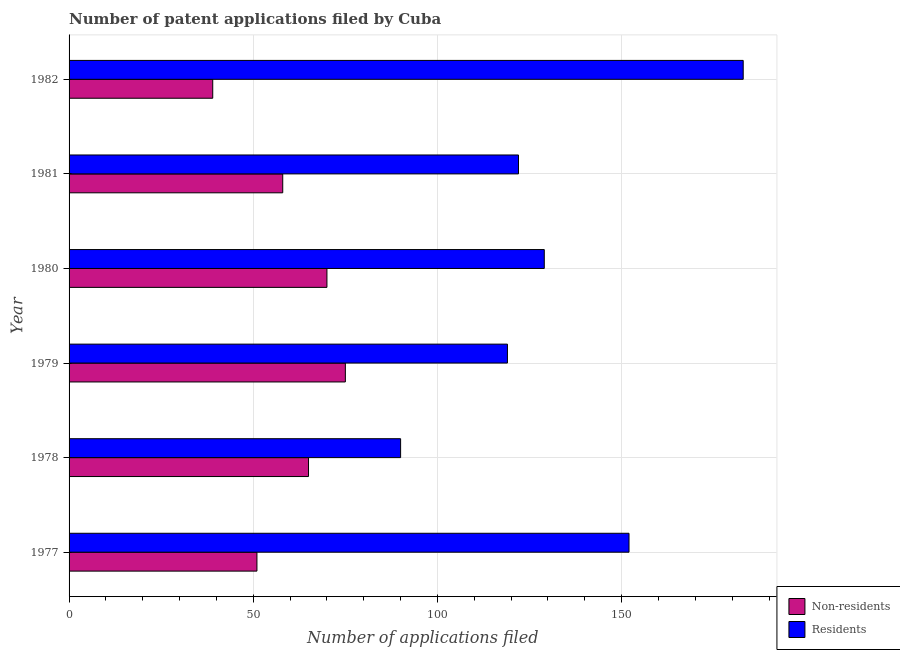How many different coloured bars are there?
Provide a short and direct response. 2. How many groups of bars are there?
Give a very brief answer. 6. What is the number of patent applications by residents in 1980?
Your answer should be very brief. 129. Across all years, what is the maximum number of patent applications by non residents?
Give a very brief answer. 75. Across all years, what is the minimum number of patent applications by residents?
Your answer should be compact. 90. In which year was the number of patent applications by residents maximum?
Provide a short and direct response. 1982. In which year was the number of patent applications by residents minimum?
Offer a terse response. 1978. What is the total number of patent applications by non residents in the graph?
Keep it short and to the point. 358. What is the difference between the number of patent applications by residents in 1978 and that in 1979?
Your answer should be compact. -29. What is the difference between the number of patent applications by residents in 1980 and the number of patent applications by non residents in 1977?
Give a very brief answer. 78. What is the average number of patent applications by residents per year?
Your answer should be compact. 132.5. In the year 1978, what is the difference between the number of patent applications by residents and number of patent applications by non residents?
Offer a terse response. 25. What is the ratio of the number of patent applications by residents in 1979 to that in 1980?
Your answer should be compact. 0.92. Is the number of patent applications by non residents in 1978 less than that in 1981?
Offer a terse response. No. What is the difference between the highest and the lowest number of patent applications by residents?
Provide a short and direct response. 93. In how many years, is the number of patent applications by non residents greater than the average number of patent applications by non residents taken over all years?
Give a very brief answer. 3. Is the sum of the number of patent applications by non residents in 1980 and 1981 greater than the maximum number of patent applications by residents across all years?
Keep it short and to the point. No. What does the 1st bar from the top in 1979 represents?
Your answer should be very brief. Residents. What does the 1st bar from the bottom in 1978 represents?
Keep it short and to the point. Non-residents. How many years are there in the graph?
Your answer should be compact. 6. Does the graph contain grids?
Your answer should be very brief. Yes. How are the legend labels stacked?
Provide a succinct answer. Vertical. What is the title of the graph?
Ensure brevity in your answer.  Number of patent applications filed by Cuba. What is the label or title of the X-axis?
Offer a very short reply. Number of applications filed. What is the label or title of the Y-axis?
Provide a succinct answer. Year. What is the Number of applications filed in Residents in 1977?
Ensure brevity in your answer.  152. What is the Number of applications filed of Residents in 1979?
Your response must be concise. 119. What is the Number of applications filed of Residents in 1980?
Provide a succinct answer. 129. What is the Number of applications filed in Residents in 1981?
Provide a succinct answer. 122. What is the Number of applications filed of Residents in 1982?
Ensure brevity in your answer.  183. Across all years, what is the maximum Number of applications filed in Residents?
Make the answer very short. 183. Across all years, what is the minimum Number of applications filed in Residents?
Keep it short and to the point. 90. What is the total Number of applications filed in Non-residents in the graph?
Offer a very short reply. 358. What is the total Number of applications filed in Residents in the graph?
Offer a terse response. 795. What is the difference between the Number of applications filed of Non-residents in 1977 and that in 1979?
Your answer should be compact. -24. What is the difference between the Number of applications filed in Residents in 1977 and that in 1980?
Ensure brevity in your answer.  23. What is the difference between the Number of applications filed in Residents in 1977 and that in 1981?
Offer a terse response. 30. What is the difference between the Number of applications filed in Residents in 1977 and that in 1982?
Provide a succinct answer. -31. What is the difference between the Number of applications filed of Non-residents in 1978 and that in 1979?
Your answer should be compact. -10. What is the difference between the Number of applications filed in Residents in 1978 and that in 1979?
Provide a short and direct response. -29. What is the difference between the Number of applications filed in Residents in 1978 and that in 1980?
Provide a short and direct response. -39. What is the difference between the Number of applications filed of Residents in 1978 and that in 1981?
Your response must be concise. -32. What is the difference between the Number of applications filed in Residents in 1978 and that in 1982?
Give a very brief answer. -93. What is the difference between the Number of applications filed in Residents in 1979 and that in 1981?
Your response must be concise. -3. What is the difference between the Number of applications filed in Non-residents in 1979 and that in 1982?
Your answer should be very brief. 36. What is the difference between the Number of applications filed of Residents in 1979 and that in 1982?
Offer a terse response. -64. What is the difference between the Number of applications filed of Non-residents in 1980 and that in 1982?
Provide a short and direct response. 31. What is the difference between the Number of applications filed of Residents in 1980 and that in 1982?
Keep it short and to the point. -54. What is the difference between the Number of applications filed of Non-residents in 1981 and that in 1982?
Your response must be concise. 19. What is the difference between the Number of applications filed of Residents in 1981 and that in 1982?
Keep it short and to the point. -61. What is the difference between the Number of applications filed in Non-residents in 1977 and the Number of applications filed in Residents in 1978?
Keep it short and to the point. -39. What is the difference between the Number of applications filed in Non-residents in 1977 and the Number of applications filed in Residents in 1979?
Ensure brevity in your answer.  -68. What is the difference between the Number of applications filed of Non-residents in 1977 and the Number of applications filed of Residents in 1980?
Ensure brevity in your answer.  -78. What is the difference between the Number of applications filed in Non-residents in 1977 and the Number of applications filed in Residents in 1981?
Give a very brief answer. -71. What is the difference between the Number of applications filed in Non-residents in 1977 and the Number of applications filed in Residents in 1982?
Your response must be concise. -132. What is the difference between the Number of applications filed in Non-residents in 1978 and the Number of applications filed in Residents in 1979?
Provide a succinct answer. -54. What is the difference between the Number of applications filed of Non-residents in 1978 and the Number of applications filed of Residents in 1980?
Offer a very short reply. -64. What is the difference between the Number of applications filed of Non-residents in 1978 and the Number of applications filed of Residents in 1981?
Give a very brief answer. -57. What is the difference between the Number of applications filed in Non-residents in 1978 and the Number of applications filed in Residents in 1982?
Offer a terse response. -118. What is the difference between the Number of applications filed in Non-residents in 1979 and the Number of applications filed in Residents in 1980?
Offer a very short reply. -54. What is the difference between the Number of applications filed of Non-residents in 1979 and the Number of applications filed of Residents in 1981?
Make the answer very short. -47. What is the difference between the Number of applications filed in Non-residents in 1979 and the Number of applications filed in Residents in 1982?
Your answer should be very brief. -108. What is the difference between the Number of applications filed of Non-residents in 1980 and the Number of applications filed of Residents in 1981?
Your response must be concise. -52. What is the difference between the Number of applications filed of Non-residents in 1980 and the Number of applications filed of Residents in 1982?
Ensure brevity in your answer.  -113. What is the difference between the Number of applications filed of Non-residents in 1981 and the Number of applications filed of Residents in 1982?
Keep it short and to the point. -125. What is the average Number of applications filed of Non-residents per year?
Your response must be concise. 59.67. What is the average Number of applications filed in Residents per year?
Keep it short and to the point. 132.5. In the year 1977, what is the difference between the Number of applications filed of Non-residents and Number of applications filed of Residents?
Give a very brief answer. -101. In the year 1978, what is the difference between the Number of applications filed in Non-residents and Number of applications filed in Residents?
Ensure brevity in your answer.  -25. In the year 1979, what is the difference between the Number of applications filed in Non-residents and Number of applications filed in Residents?
Your answer should be compact. -44. In the year 1980, what is the difference between the Number of applications filed in Non-residents and Number of applications filed in Residents?
Provide a succinct answer. -59. In the year 1981, what is the difference between the Number of applications filed of Non-residents and Number of applications filed of Residents?
Your answer should be compact. -64. In the year 1982, what is the difference between the Number of applications filed in Non-residents and Number of applications filed in Residents?
Provide a short and direct response. -144. What is the ratio of the Number of applications filed in Non-residents in 1977 to that in 1978?
Ensure brevity in your answer.  0.78. What is the ratio of the Number of applications filed of Residents in 1977 to that in 1978?
Provide a short and direct response. 1.69. What is the ratio of the Number of applications filed in Non-residents in 1977 to that in 1979?
Make the answer very short. 0.68. What is the ratio of the Number of applications filed of Residents in 1977 to that in 1979?
Your response must be concise. 1.28. What is the ratio of the Number of applications filed in Non-residents in 1977 to that in 1980?
Your response must be concise. 0.73. What is the ratio of the Number of applications filed of Residents in 1977 to that in 1980?
Offer a terse response. 1.18. What is the ratio of the Number of applications filed of Non-residents in 1977 to that in 1981?
Your response must be concise. 0.88. What is the ratio of the Number of applications filed of Residents in 1977 to that in 1981?
Make the answer very short. 1.25. What is the ratio of the Number of applications filed in Non-residents in 1977 to that in 1982?
Your answer should be very brief. 1.31. What is the ratio of the Number of applications filed of Residents in 1977 to that in 1982?
Give a very brief answer. 0.83. What is the ratio of the Number of applications filed in Non-residents in 1978 to that in 1979?
Your answer should be compact. 0.87. What is the ratio of the Number of applications filed of Residents in 1978 to that in 1979?
Provide a succinct answer. 0.76. What is the ratio of the Number of applications filed of Non-residents in 1978 to that in 1980?
Provide a short and direct response. 0.93. What is the ratio of the Number of applications filed in Residents in 1978 to that in 1980?
Ensure brevity in your answer.  0.7. What is the ratio of the Number of applications filed of Non-residents in 1978 to that in 1981?
Give a very brief answer. 1.12. What is the ratio of the Number of applications filed of Residents in 1978 to that in 1981?
Offer a very short reply. 0.74. What is the ratio of the Number of applications filed in Non-residents in 1978 to that in 1982?
Provide a succinct answer. 1.67. What is the ratio of the Number of applications filed in Residents in 1978 to that in 1982?
Give a very brief answer. 0.49. What is the ratio of the Number of applications filed of Non-residents in 1979 to that in 1980?
Your answer should be very brief. 1.07. What is the ratio of the Number of applications filed of Residents in 1979 to that in 1980?
Keep it short and to the point. 0.92. What is the ratio of the Number of applications filed of Non-residents in 1979 to that in 1981?
Give a very brief answer. 1.29. What is the ratio of the Number of applications filed in Residents in 1979 to that in 1981?
Give a very brief answer. 0.98. What is the ratio of the Number of applications filed in Non-residents in 1979 to that in 1982?
Provide a short and direct response. 1.92. What is the ratio of the Number of applications filed of Residents in 1979 to that in 1982?
Give a very brief answer. 0.65. What is the ratio of the Number of applications filed in Non-residents in 1980 to that in 1981?
Offer a very short reply. 1.21. What is the ratio of the Number of applications filed in Residents in 1980 to that in 1981?
Offer a terse response. 1.06. What is the ratio of the Number of applications filed in Non-residents in 1980 to that in 1982?
Offer a terse response. 1.79. What is the ratio of the Number of applications filed of Residents in 1980 to that in 1982?
Provide a succinct answer. 0.7. What is the ratio of the Number of applications filed in Non-residents in 1981 to that in 1982?
Your response must be concise. 1.49. What is the ratio of the Number of applications filed of Residents in 1981 to that in 1982?
Ensure brevity in your answer.  0.67. What is the difference between the highest and the second highest Number of applications filed in Non-residents?
Give a very brief answer. 5. What is the difference between the highest and the lowest Number of applications filed in Residents?
Offer a terse response. 93. 